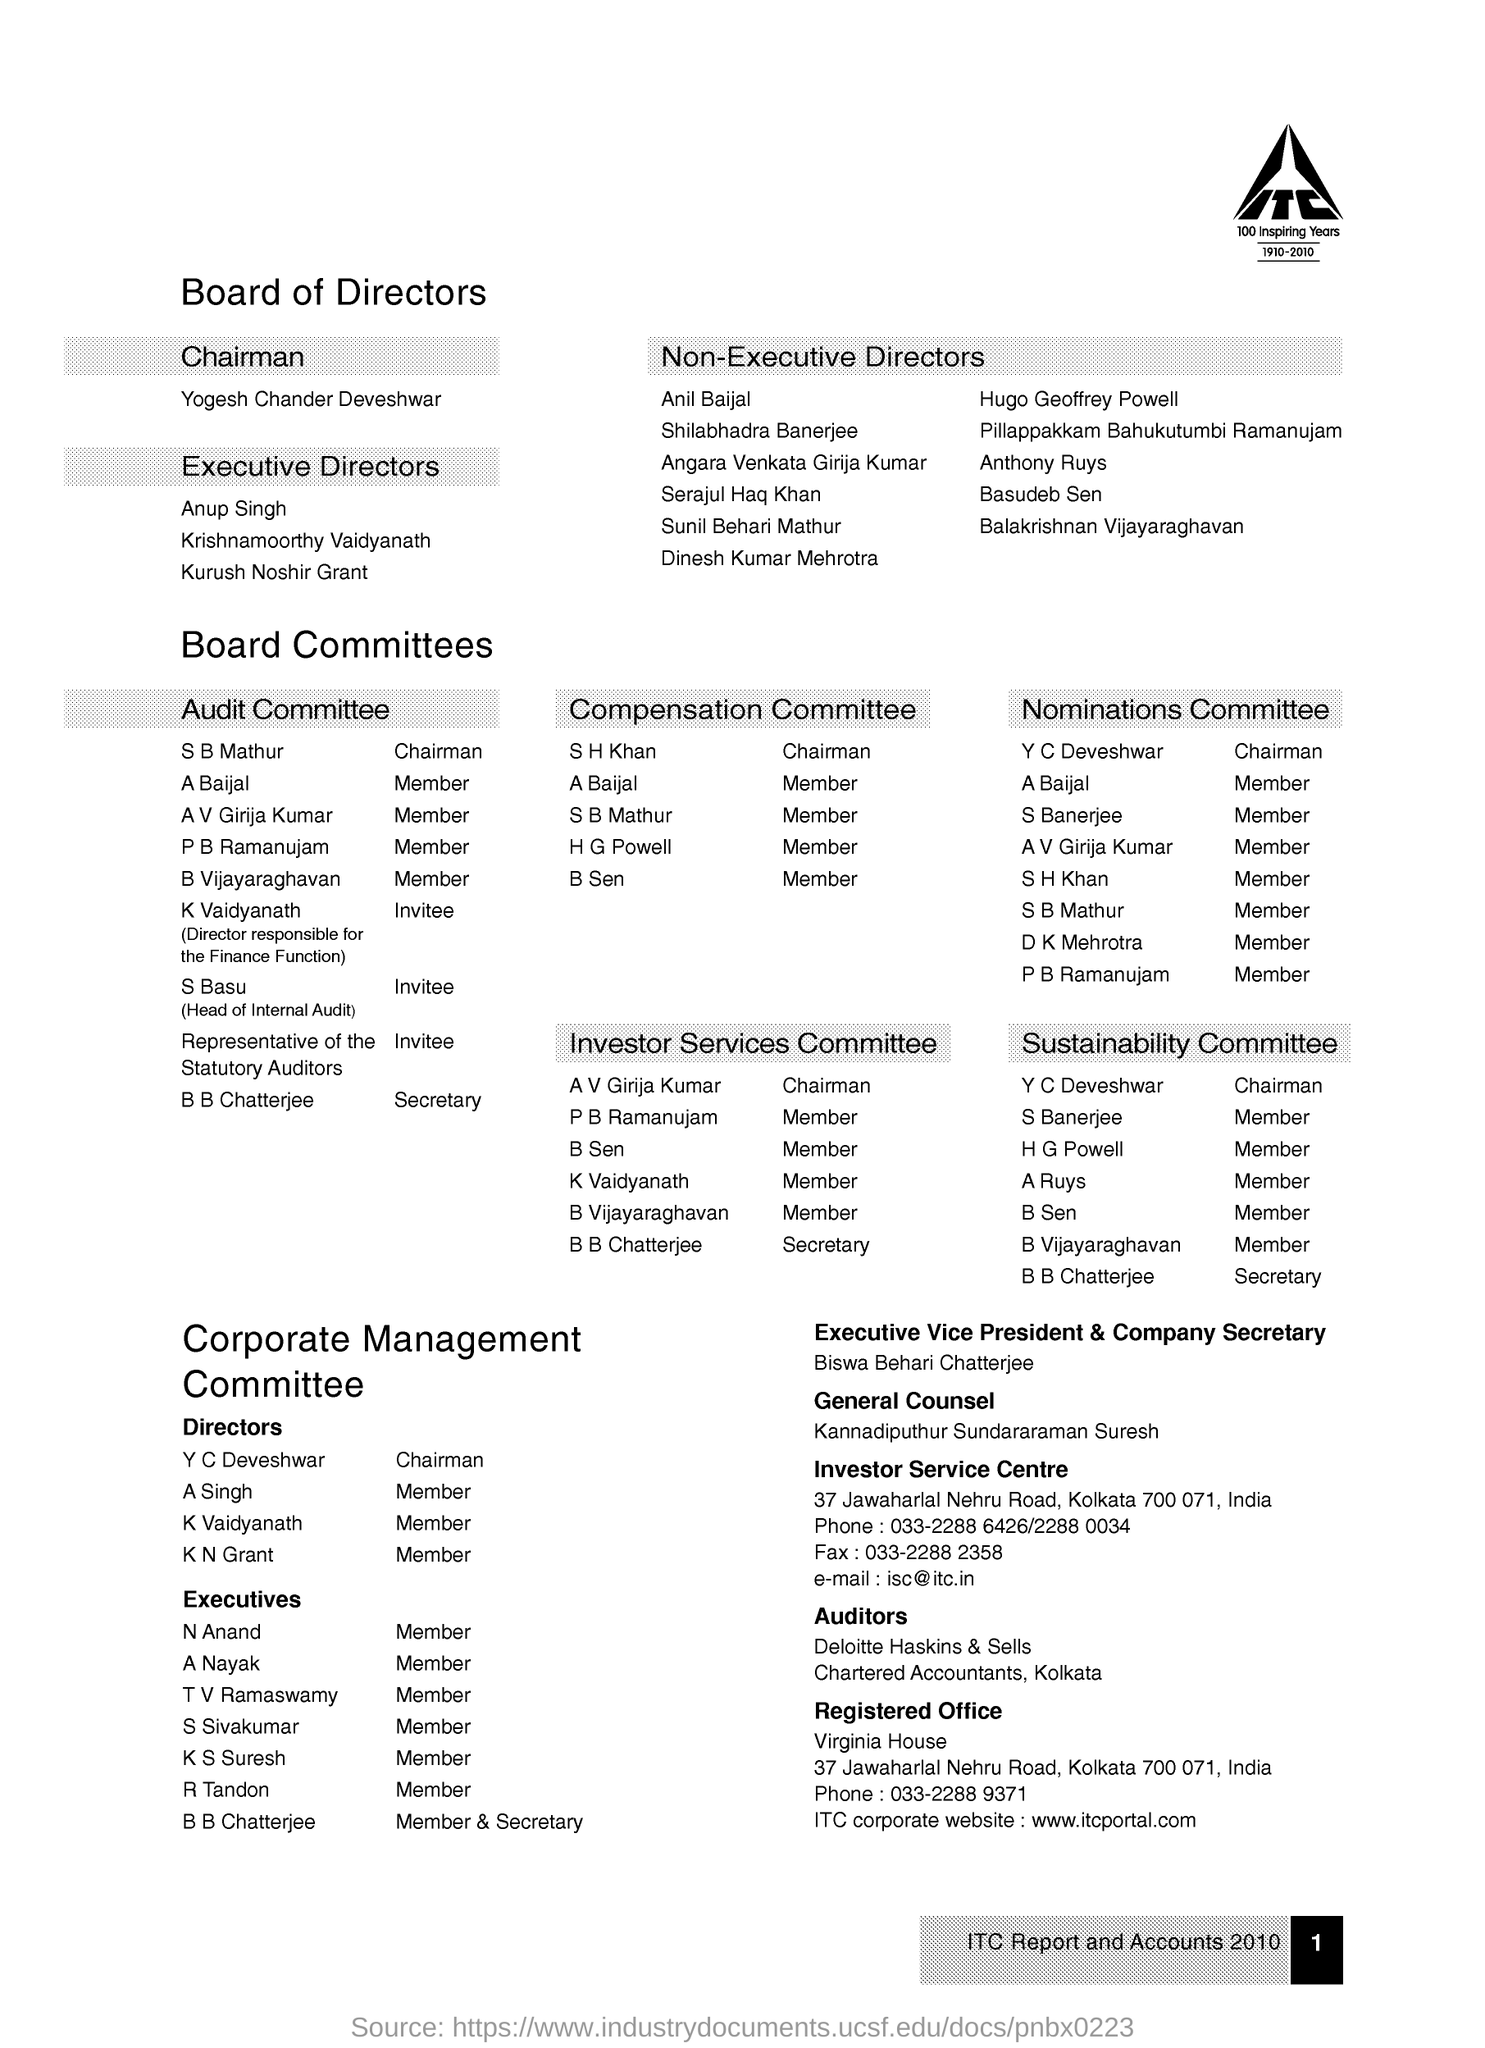Point out several critical features in this image. Biswa Behari Chatterjee is the executive vice president and company secretary of a certain organization. The chairman of the company is Yogesh Chander Deveshwar. The e-mail of the Investor Service Centre is [isc@itc.in](mailto:isc@itc.in). The registered office of the company is located in Kolkata. Suresh Kannadiputhur Sundararaman is the General Counsel. 